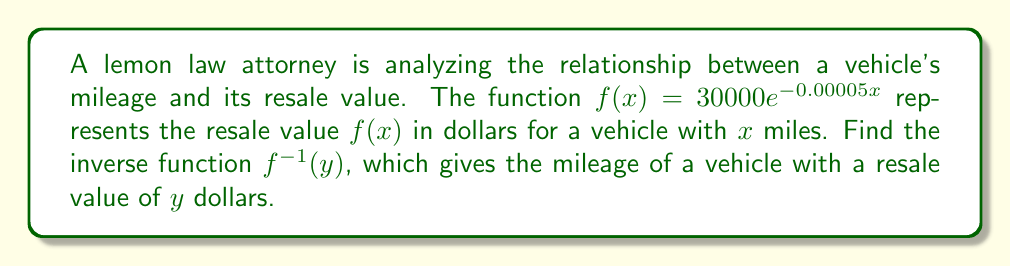What is the answer to this math problem? 1) To find the inverse function, we first replace $f(x)$ with $y$:
   $y = 30000e^{-0.00005x}$

2) Now, we isolate the exponential term:
   $\frac{y}{30000} = e^{-0.00005x}$

3) Take the natural logarithm of both sides:
   $\ln(\frac{y}{30000}) = \ln(e^{-0.00005x})$

4) Simplify the right side using the property of logarithms:
   $\ln(\frac{y}{30000}) = -0.00005x$

5) Multiply both sides by -20000:
   $-20000\ln(\frac{y}{30000}) = x$

6) This gives us the inverse function. Replace $x$ with $f^{-1}(y)$:
   $f^{-1}(y) = -20000\ln(\frac{y}{30000})$

This inverse function gives the mileage of a vehicle with a resale value of $y$ dollars.
Answer: $f^{-1}(y) = -20000\ln(\frac{y}{30000})$ 